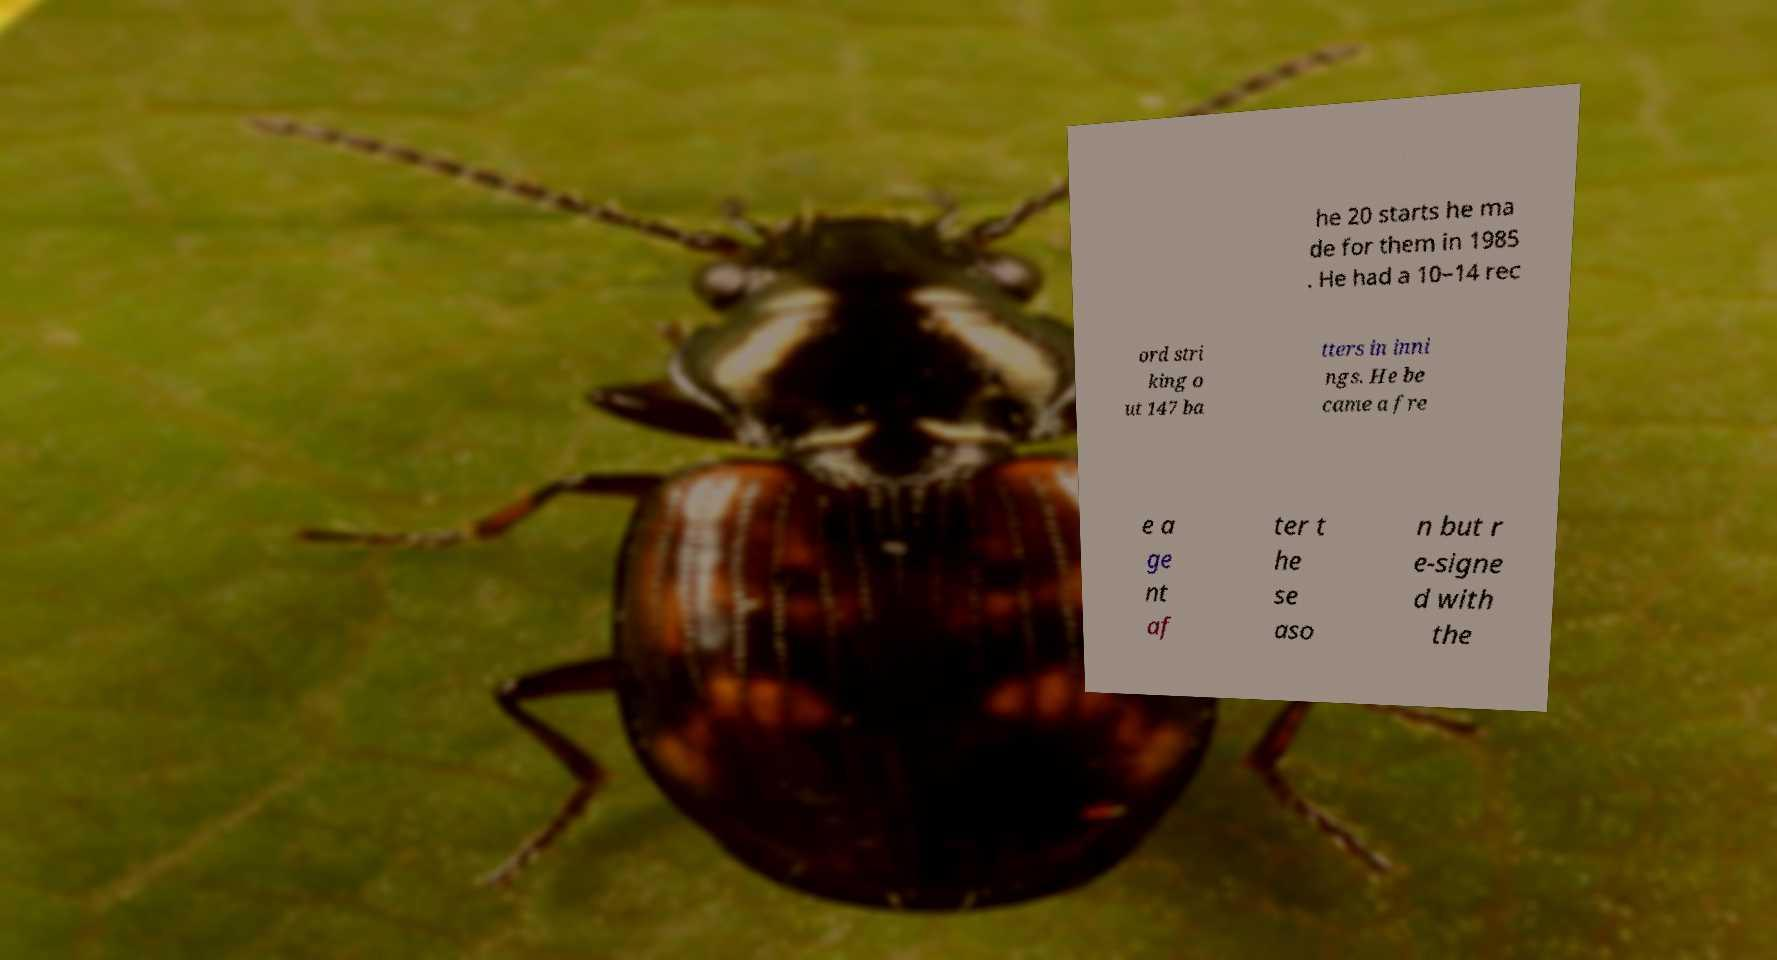I need the written content from this picture converted into text. Can you do that? he 20 starts he ma de for them in 1985 . He had a 10–14 rec ord stri king o ut 147 ba tters in inni ngs. He be came a fre e a ge nt af ter t he se aso n but r e-signe d with the 